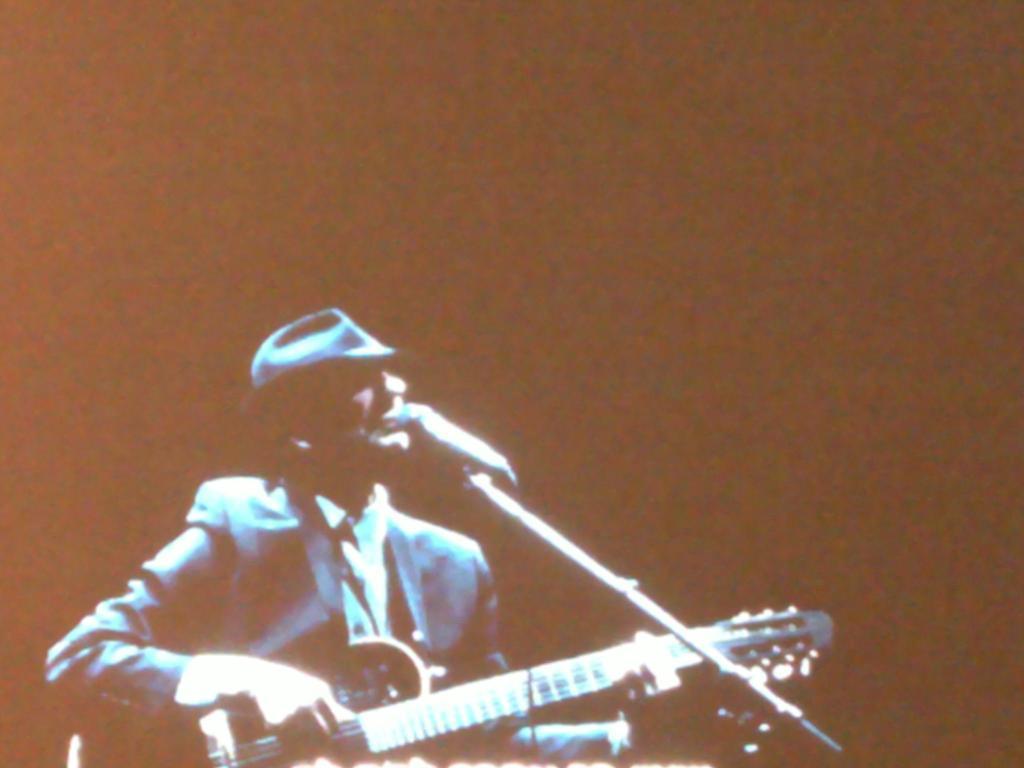Can you describe this image briefly? In this picture we can see a man who is singing on the mike and he is playing guitar. 